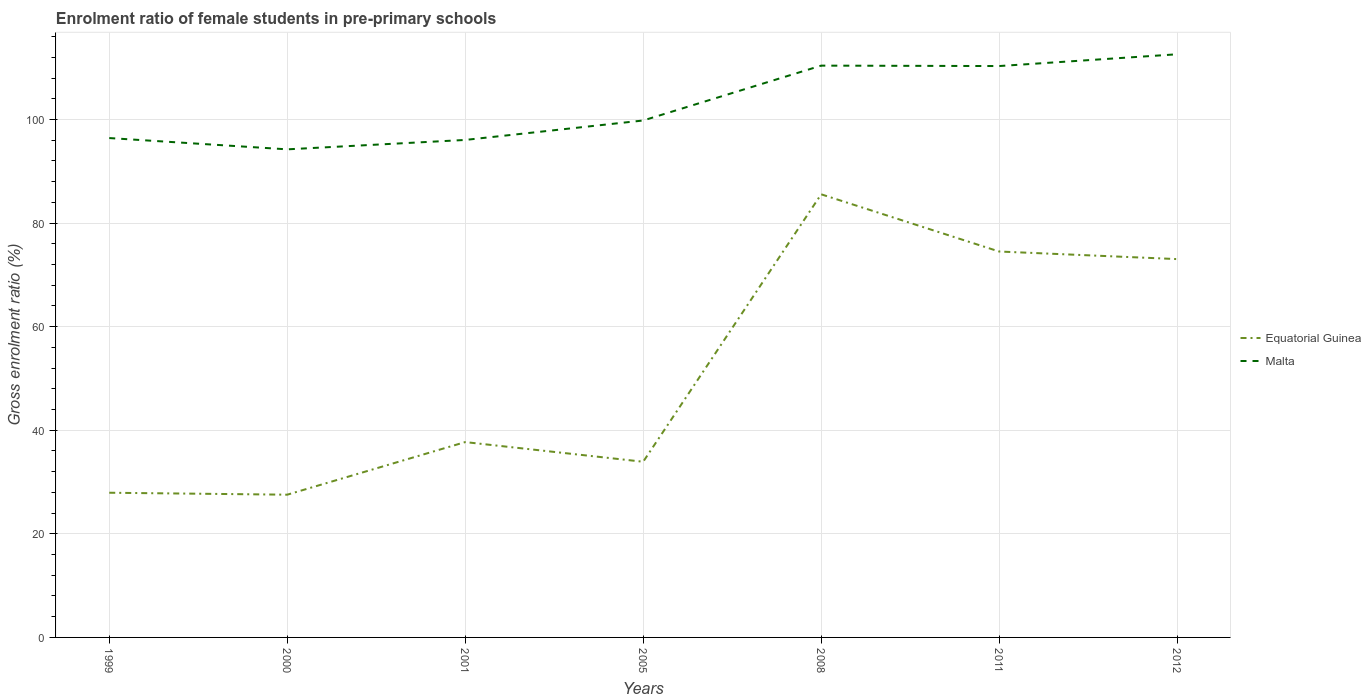How many different coloured lines are there?
Make the answer very short. 2. Is the number of lines equal to the number of legend labels?
Give a very brief answer. Yes. Across all years, what is the maximum enrolment ratio of female students in pre-primary schools in Equatorial Guinea?
Offer a terse response. 27.56. In which year was the enrolment ratio of female students in pre-primary schools in Malta maximum?
Your response must be concise. 2000. What is the total enrolment ratio of female students in pre-primary schools in Equatorial Guinea in the graph?
Offer a terse response. -40.59. What is the difference between the highest and the second highest enrolment ratio of female students in pre-primary schools in Malta?
Provide a succinct answer. 18.36. Is the enrolment ratio of female students in pre-primary schools in Malta strictly greater than the enrolment ratio of female students in pre-primary schools in Equatorial Guinea over the years?
Keep it short and to the point. No. How many years are there in the graph?
Make the answer very short. 7. What is the difference between two consecutive major ticks on the Y-axis?
Offer a very short reply. 20. Are the values on the major ticks of Y-axis written in scientific E-notation?
Provide a succinct answer. No. Does the graph contain grids?
Offer a terse response. Yes. Where does the legend appear in the graph?
Your response must be concise. Center right. What is the title of the graph?
Your answer should be compact. Enrolment ratio of female students in pre-primary schools. Does "Bermuda" appear as one of the legend labels in the graph?
Offer a very short reply. No. What is the Gross enrolment ratio (%) of Equatorial Guinea in 1999?
Offer a very short reply. 27.94. What is the Gross enrolment ratio (%) in Malta in 1999?
Make the answer very short. 96.42. What is the Gross enrolment ratio (%) of Equatorial Guinea in 2000?
Keep it short and to the point. 27.56. What is the Gross enrolment ratio (%) of Malta in 2000?
Make the answer very short. 94.24. What is the Gross enrolment ratio (%) in Equatorial Guinea in 2001?
Offer a terse response. 37.72. What is the Gross enrolment ratio (%) of Malta in 2001?
Your answer should be compact. 96.06. What is the Gross enrolment ratio (%) of Equatorial Guinea in 2005?
Your answer should be compact. 33.92. What is the Gross enrolment ratio (%) of Malta in 2005?
Provide a short and direct response. 99.81. What is the Gross enrolment ratio (%) in Equatorial Guinea in 2008?
Your answer should be very brief. 85.56. What is the Gross enrolment ratio (%) in Malta in 2008?
Ensure brevity in your answer.  110.4. What is the Gross enrolment ratio (%) of Equatorial Guinea in 2011?
Keep it short and to the point. 74.51. What is the Gross enrolment ratio (%) of Malta in 2011?
Your answer should be compact. 110.32. What is the Gross enrolment ratio (%) of Equatorial Guinea in 2012?
Provide a succinct answer. 73.05. What is the Gross enrolment ratio (%) of Malta in 2012?
Ensure brevity in your answer.  112.6. Across all years, what is the maximum Gross enrolment ratio (%) of Equatorial Guinea?
Your answer should be very brief. 85.56. Across all years, what is the maximum Gross enrolment ratio (%) of Malta?
Your answer should be very brief. 112.6. Across all years, what is the minimum Gross enrolment ratio (%) in Equatorial Guinea?
Provide a succinct answer. 27.56. Across all years, what is the minimum Gross enrolment ratio (%) of Malta?
Make the answer very short. 94.24. What is the total Gross enrolment ratio (%) of Equatorial Guinea in the graph?
Ensure brevity in your answer.  360.26. What is the total Gross enrolment ratio (%) in Malta in the graph?
Your response must be concise. 719.85. What is the difference between the Gross enrolment ratio (%) in Equatorial Guinea in 1999 and that in 2000?
Make the answer very short. 0.38. What is the difference between the Gross enrolment ratio (%) in Malta in 1999 and that in 2000?
Keep it short and to the point. 2.18. What is the difference between the Gross enrolment ratio (%) of Equatorial Guinea in 1999 and that in 2001?
Make the answer very short. -9.78. What is the difference between the Gross enrolment ratio (%) in Malta in 1999 and that in 2001?
Give a very brief answer. 0.36. What is the difference between the Gross enrolment ratio (%) in Equatorial Guinea in 1999 and that in 2005?
Your response must be concise. -5.98. What is the difference between the Gross enrolment ratio (%) in Malta in 1999 and that in 2005?
Offer a very short reply. -3.39. What is the difference between the Gross enrolment ratio (%) of Equatorial Guinea in 1999 and that in 2008?
Offer a very short reply. -57.62. What is the difference between the Gross enrolment ratio (%) in Malta in 1999 and that in 2008?
Your answer should be very brief. -13.98. What is the difference between the Gross enrolment ratio (%) in Equatorial Guinea in 1999 and that in 2011?
Your response must be concise. -46.58. What is the difference between the Gross enrolment ratio (%) of Malta in 1999 and that in 2011?
Your response must be concise. -13.9. What is the difference between the Gross enrolment ratio (%) of Equatorial Guinea in 1999 and that in 2012?
Make the answer very short. -45.11. What is the difference between the Gross enrolment ratio (%) in Malta in 1999 and that in 2012?
Make the answer very short. -16.18. What is the difference between the Gross enrolment ratio (%) of Equatorial Guinea in 2000 and that in 2001?
Your answer should be compact. -10.16. What is the difference between the Gross enrolment ratio (%) in Malta in 2000 and that in 2001?
Give a very brief answer. -1.82. What is the difference between the Gross enrolment ratio (%) of Equatorial Guinea in 2000 and that in 2005?
Ensure brevity in your answer.  -6.36. What is the difference between the Gross enrolment ratio (%) of Malta in 2000 and that in 2005?
Offer a terse response. -5.57. What is the difference between the Gross enrolment ratio (%) in Equatorial Guinea in 2000 and that in 2008?
Your answer should be compact. -58. What is the difference between the Gross enrolment ratio (%) in Malta in 2000 and that in 2008?
Offer a terse response. -16.16. What is the difference between the Gross enrolment ratio (%) in Equatorial Guinea in 2000 and that in 2011?
Offer a very short reply. -46.95. What is the difference between the Gross enrolment ratio (%) in Malta in 2000 and that in 2011?
Your answer should be compact. -16.08. What is the difference between the Gross enrolment ratio (%) in Equatorial Guinea in 2000 and that in 2012?
Your answer should be compact. -45.49. What is the difference between the Gross enrolment ratio (%) in Malta in 2000 and that in 2012?
Keep it short and to the point. -18.36. What is the difference between the Gross enrolment ratio (%) of Equatorial Guinea in 2001 and that in 2005?
Ensure brevity in your answer.  3.8. What is the difference between the Gross enrolment ratio (%) of Malta in 2001 and that in 2005?
Keep it short and to the point. -3.76. What is the difference between the Gross enrolment ratio (%) of Equatorial Guinea in 2001 and that in 2008?
Your response must be concise. -47.84. What is the difference between the Gross enrolment ratio (%) of Malta in 2001 and that in 2008?
Your answer should be very brief. -14.35. What is the difference between the Gross enrolment ratio (%) of Equatorial Guinea in 2001 and that in 2011?
Your answer should be compact. -36.8. What is the difference between the Gross enrolment ratio (%) of Malta in 2001 and that in 2011?
Your answer should be very brief. -14.27. What is the difference between the Gross enrolment ratio (%) in Equatorial Guinea in 2001 and that in 2012?
Ensure brevity in your answer.  -35.33. What is the difference between the Gross enrolment ratio (%) of Malta in 2001 and that in 2012?
Offer a very short reply. -16.54. What is the difference between the Gross enrolment ratio (%) of Equatorial Guinea in 2005 and that in 2008?
Give a very brief answer. -51.64. What is the difference between the Gross enrolment ratio (%) in Malta in 2005 and that in 2008?
Provide a succinct answer. -10.59. What is the difference between the Gross enrolment ratio (%) in Equatorial Guinea in 2005 and that in 2011?
Give a very brief answer. -40.59. What is the difference between the Gross enrolment ratio (%) in Malta in 2005 and that in 2011?
Provide a succinct answer. -10.51. What is the difference between the Gross enrolment ratio (%) in Equatorial Guinea in 2005 and that in 2012?
Your response must be concise. -39.13. What is the difference between the Gross enrolment ratio (%) of Malta in 2005 and that in 2012?
Give a very brief answer. -12.78. What is the difference between the Gross enrolment ratio (%) in Equatorial Guinea in 2008 and that in 2011?
Provide a succinct answer. 11.05. What is the difference between the Gross enrolment ratio (%) of Malta in 2008 and that in 2011?
Keep it short and to the point. 0.08. What is the difference between the Gross enrolment ratio (%) of Equatorial Guinea in 2008 and that in 2012?
Your answer should be compact. 12.51. What is the difference between the Gross enrolment ratio (%) in Malta in 2008 and that in 2012?
Give a very brief answer. -2.19. What is the difference between the Gross enrolment ratio (%) in Equatorial Guinea in 2011 and that in 2012?
Offer a terse response. 1.46. What is the difference between the Gross enrolment ratio (%) of Malta in 2011 and that in 2012?
Provide a succinct answer. -2.27. What is the difference between the Gross enrolment ratio (%) of Equatorial Guinea in 1999 and the Gross enrolment ratio (%) of Malta in 2000?
Provide a succinct answer. -66.3. What is the difference between the Gross enrolment ratio (%) in Equatorial Guinea in 1999 and the Gross enrolment ratio (%) in Malta in 2001?
Keep it short and to the point. -68.12. What is the difference between the Gross enrolment ratio (%) of Equatorial Guinea in 1999 and the Gross enrolment ratio (%) of Malta in 2005?
Offer a very short reply. -71.88. What is the difference between the Gross enrolment ratio (%) in Equatorial Guinea in 1999 and the Gross enrolment ratio (%) in Malta in 2008?
Offer a very short reply. -82.47. What is the difference between the Gross enrolment ratio (%) of Equatorial Guinea in 1999 and the Gross enrolment ratio (%) of Malta in 2011?
Provide a short and direct response. -82.39. What is the difference between the Gross enrolment ratio (%) in Equatorial Guinea in 1999 and the Gross enrolment ratio (%) in Malta in 2012?
Ensure brevity in your answer.  -84.66. What is the difference between the Gross enrolment ratio (%) of Equatorial Guinea in 2000 and the Gross enrolment ratio (%) of Malta in 2001?
Provide a short and direct response. -68.5. What is the difference between the Gross enrolment ratio (%) in Equatorial Guinea in 2000 and the Gross enrolment ratio (%) in Malta in 2005?
Your response must be concise. -72.25. What is the difference between the Gross enrolment ratio (%) in Equatorial Guinea in 2000 and the Gross enrolment ratio (%) in Malta in 2008?
Provide a short and direct response. -82.84. What is the difference between the Gross enrolment ratio (%) in Equatorial Guinea in 2000 and the Gross enrolment ratio (%) in Malta in 2011?
Provide a short and direct response. -82.76. What is the difference between the Gross enrolment ratio (%) of Equatorial Guinea in 2000 and the Gross enrolment ratio (%) of Malta in 2012?
Provide a succinct answer. -85.04. What is the difference between the Gross enrolment ratio (%) of Equatorial Guinea in 2001 and the Gross enrolment ratio (%) of Malta in 2005?
Offer a terse response. -62.1. What is the difference between the Gross enrolment ratio (%) of Equatorial Guinea in 2001 and the Gross enrolment ratio (%) of Malta in 2008?
Ensure brevity in your answer.  -72.69. What is the difference between the Gross enrolment ratio (%) of Equatorial Guinea in 2001 and the Gross enrolment ratio (%) of Malta in 2011?
Your answer should be very brief. -72.61. What is the difference between the Gross enrolment ratio (%) of Equatorial Guinea in 2001 and the Gross enrolment ratio (%) of Malta in 2012?
Your answer should be compact. -74.88. What is the difference between the Gross enrolment ratio (%) in Equatorial Guinea in 2005 and the Gross enrolment ratio (%) in Malta in 2008?
Ensure brevity in your answer.  -76.48. What is the difference between the Gross enrolment ratio (%) in Equatorial Guinea in 2005 and the Gross enrolment ratio (%) in Malta in 2011?
Offer a very short reply. -76.4. What is the difference between the Gross enrolment ratio (%) in Equatorial Guinea in 2005 and the Gross enrolment ratio (%) in Malta in 2012?
Your response must be concise. -78.68. What is the difference between the Gross enrolment ratio (%) of Equatorial Guinea in 2008 and the Gross enrolment ratio (%) of Malta in 2011?
Offer a very short reply. -24.76. What is the difference between the Gross enrolment ratio (%) of Equatorial Guinea in 2008 and the Gross enrolment ratio (%) of Malta in 2012?
Your answer should be very brief. -27.04. What is the difference between the Gross enrolment ratio (%) in Equatorial Guinea in 2011 and the Gross enrolment ratio (%) in Malta in 2012?
Ensure brevity in your answer.  -38.08. What is the average Gross enrolment ratio (%) of Equatorial Guinea per year?
Make the answer very short. 51.47. What is the average Gross enrolment ratio (%) of Malta per year?
Your answer should be compact. 102.84. In the year 1999, what is the difference between the Gross enrolment ratio (%) of Equatorial Guinea and Gross enrolment ratio (%) of Malta?
Provide a succinct answer. -68.48. In the year 2000, what is the difference between the Gross enrolment ratio (%) in Equatorial Guinea and Gross enrolment ratio (%) in Malta?
Ensure brevity in your answer.  -66.68. In the year 2001, what is the difference between the Gross enrolment ratio (%) in Equatorial Guinea and Gross enrolment ratio (%) in Malta?
Your response must be concise. -58.34. In the year 2005, what is the difference between the Gross enrolment ratio (%) of Equatorial Guinea and Gross enrolment ratio (%) of Malta?
Provide a short and direct response. -65.89. In the year 2008, what is the difference between the Gross enrolment ratio (%) of Equatorial Guinea and Gross enrolment ratio (%) of Malta?
Provide a succinct answer. -24.84. In the year 2011, what is the difference between the Gross enrolment ratio (%) in Equatorial Guinea and Gross enrolment ratio (%) in Malta?
Make the answer very short. -35.81. In the year 2012, what is the difference between the Gross enrolment ratio (%) in Equatorial Guinea and Gross enrolment ratio (%) in Malta?
Ensure brevity in your answer.  -39.55. What is the ratio of the Gross enrolment ratio (%) in Equatorial Guinea in 1999 to that in 2000?
Your answer should be compact. 1.01. What is the ratio of the Gross enrolment ratio (%) in Malta in 1999 to that in 2000?
Your response must be concise. 1.02. What is the ratio of the Gross enrolment ratio (%) of Equatorial Guinea in 1999 to that in 2001?
Provide a succinct answer. 0.74. What is the ratio of the Gross enrolment ratio (%) in Malta in 1999 to that in 2001?
Your answer should be very brief. 1. What is the ratio of the Gross enrolment ratio (%) in Equatorial Guinea in 1999 to that in 2005?
Provide a short and direct response. 0.82. What is the ratio of the Gross enrolment ratio (%) in Malta in 1999 to that in 2005?
Provide a short and direct response. 0.97. What is the ratio of the Gross enrolment ratio (%) of Equatorial Guinea in 1999 to that in 2008?
Keep it short and to the point. 0.33. What is the ratio of the Gross enrolment ratio (%) in Malta in 1999 to that in 2008?
Your answer should be very brief. 0.87. What is the ratio of the Gross enrolment ratio (%) in Equatorial Guinea in 1999 to that in 2011?
Ensure brevity in your answer.  0.37. What is the ratio of the Gross enrolment ratio (%) in Malta in 1999 to that in 2011?
Your answer should be compact. 0.87. What is the ratio of the Gross enrolment ratio (%) in Equatorial Guinea in 1999 to that in 2012?
Offer a terse response. 0.38. What is the ratio of the Gross enrolment ratio (%) in Malta in 1999 to that in 2012?
Make the answer very short. 0.86. What is the ratio of the Gross enrolment ratio (%) of Equatorial Guinea in 2000 to that in 2001?
Give a very brief answer. 0.73. What is the ratio of the Gross enrolment ratio (%) in Malta in 2000 to that in 2001?
Your response must be concise. 0.98. What is the ratio of the Gross enrolment ratio (%) in Equatorial Guinea in 2000 to that in 2005?
Your answer should be compact. 0.81. What is the ratio of the Gross enrolment ratio (%) of Malta in 2000 to that in 2005?
Provide a succinct answer. 0.94. What is the ratio of the Gross enrolment ratio (%) in Equatorial Guinea in 2000 to that in 2008?
Ensure brevity in your answer.  0.32. What is the ratio of the Gross enrolment ratio (%) of Malta in 2000 to that in 2008?
Give a very brief answer. 0.85. What is the ratio of the Gross enrolment ratio (%) of Equatorial Guinea in 2000 to that in 2011?
Provide a short and direct response. 0.37. What is the ratio of the Gross enrolment ratio (%) in Malta in 2000 to that in 2011?
Ensure brevity in your answer.  0.85. What is the ratio of the Gross enrolment ratio (%) in Equatorial Guinea in 2000 to that in 2012?
Give a very brief answer. 0.38. What is the ratio of the Gross enrolment ratio (%) of Malta in 2000 to that in 2012?
Provide a short and direct response. 0.84. What is the ratio of the Gross enrolment ratio (%) in Equatorial Guinea in 2001 to that in 2005?
Your response must be concise. 1.11. What is the ratio of the Gross enrolment ratio (%) of Malta in 2001 to that in 2005?
Provide a short and direct response. 0.96. What is the ratio of the Gross enrolment ratio (%) of Equatorial Guinea in 2001 to that in 2008?
Provide a succinct answer. 0.44. What is the ratio of the Gross enrolment ratio (%) in Malta in 2001 to that in 2008?
Offer a terse response. 0.87. What is the ratio of the Gross enrolment ratio (%) in Equatorial Guinea in 2001 to that in 2011?
Offer a terse response. 0.51. What is the ratio of the Gross enrolment ratio (%) in Malta in 2001 to that in 2011?
Your response must be concise. 0.87. What is the ratio of the Gross enrolment ratio (%) of Equatorial Guinea in 2001 to that in 2012?
Offer a terse response. 0.52. What is the ratio of the Gross enrolment ratio (%) of Malta in 2001 to that in 2012?
Ensure brevity in your answer.  0.85. What is the ratio of the Gross enrolment ratio (%) in Equatorial Guinea in 2005 to that in 2008?
Provide a succinct answer. 0.4. What is the ratio of the Gross enrolment ratio (%) of Malta in 2005 to that in 2008?
Provide a short and direct response. 0.9. What is the ratio of the Gross enrolment ratio (%) of Equatorial Guinea in 2005 to that in 2011?
Provide a succinct answer. 0.46. What is the ratio of the Gross enrolment ratio (%) of Malta in 2005 to that in 2011?
Provide a short and direct response. 0.9. What is the ratio of the Gross enrolment ratio (%) in Equatorial Guinea in 2005 to that in 2012?
Your answer should be very brief. 0.46. What is the ratio of the Gross enrolment ratio (%) in Malta in 2005 to that in 2012?
Keep it short and to the point. 0.89. What is the ratio of the Gross enrolment ratio (%) in Equatorial Guinea in 2008 to that in 2011?
Provide a succinct answer. 1.15. What is the ratio of the Gross enrolment ratio (%) in Equatorial Guinea in 2008 to that in 2012?
Offer a terse response. 1.17. What is the ratio of the Gross enrolment ratio (%) in Malta in 2008 to that in 2012?
Provide a succinct answer. 0.98. What is the ratio of the Gross enrolment ratio (%) in Equatorial Guinea in 2011 to that in 2012?
Offer a very short reply. 1.02. What is the ratio of the Gross enrolment ratio (%) in Malta in 2011 to that in 2012?
Your response must be concise. 0.98. What is the difference between the highest and the second highest Gross enrolment ratio (%) of Equatorial Guinea?
Ensure brevity in your answer.  11.05. What is the difference between the highest and the second highest Gross enrolment ratio (%) in Malta?
Offer a terse response. 2.19. What is the difference between the highest and the lowest Gross enrolment ratio (%) of Equatorial Guinea?
Offer a terse response. 58. What is the difference between the highest and the lowest Gross enrolment ratio (%) of Malta?
Make the answer very short. 18.36. 